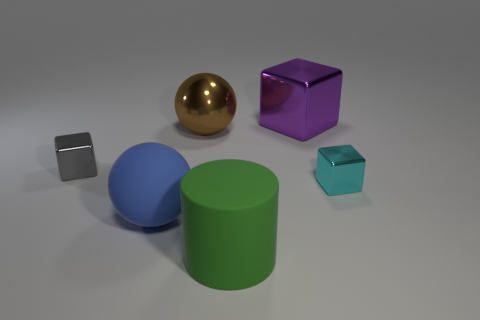Add 4 large matte things. How many objects exist? 10 Subtract all balls. How many objects are left? 4 Subtract 1 green cylinders. How many objects are left? 5 Subtract all red things. Subtract all small gray things. How many objects are left? 5 Add 4 shiny balls. How many shiny balls are left? 5 Add 2 big blue spheres. How many big blue spheres exist? 3 